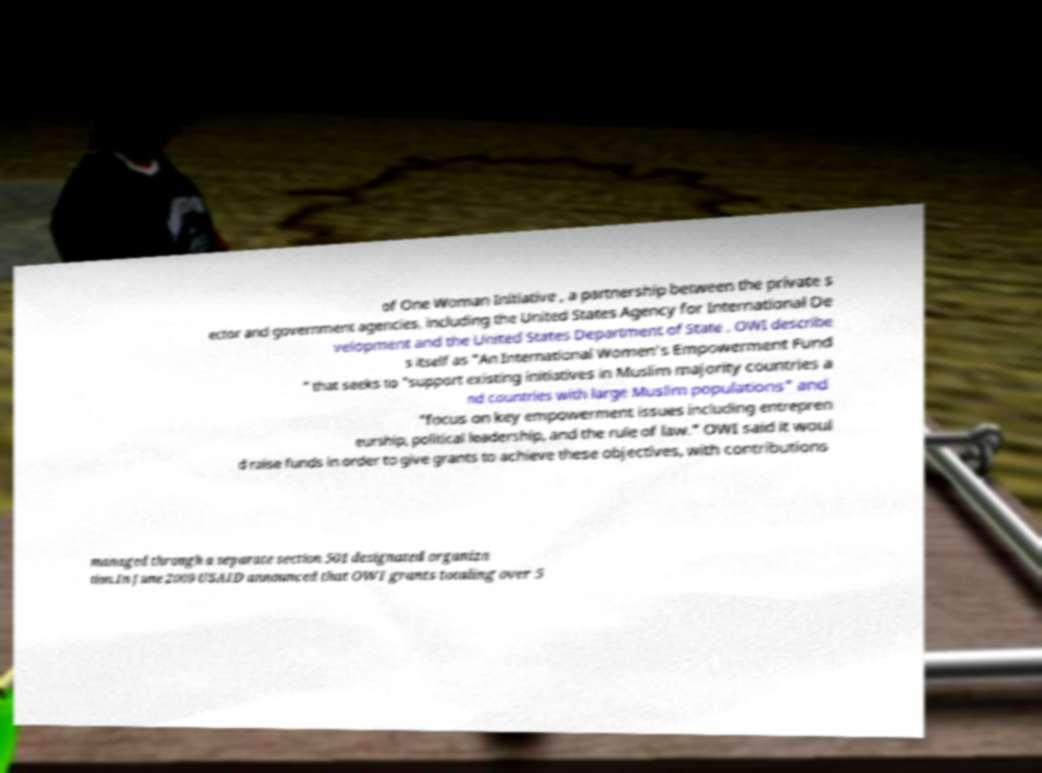Please read and relay the text visible in this image. What does it say? of One Woman Initiative , a partnership between the private s ector and government agencies, including the United States Agency for International De velopment and the United States Department of State . OWI describe s itself as "An International Women's Empowerment Fund " that seeks to "support existing initiatives in Muslim majority countries a nd countries with large Muslim populations" and "focus on key empowerment issues including entrepren eurship, political leadership, and the rule of law." OWI said it woul d raise funds in order to give grants to achieve these objectives, with contributions managed through a separate section 501 designated organiza tion.In June 2009 USAID announced that OWI grants totaling over 5 